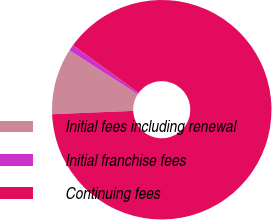Convert chart to OTSL. <chart><loc_0><loc_0><loc_500><loc_500><pie_chart><fcel>Initial fees including renewal<fcel>Initial franchise fees<fcel>Continuing fees<nl><fcel>9.75%<fcel>0.91%<fcel>89.34%<nl></chart> 